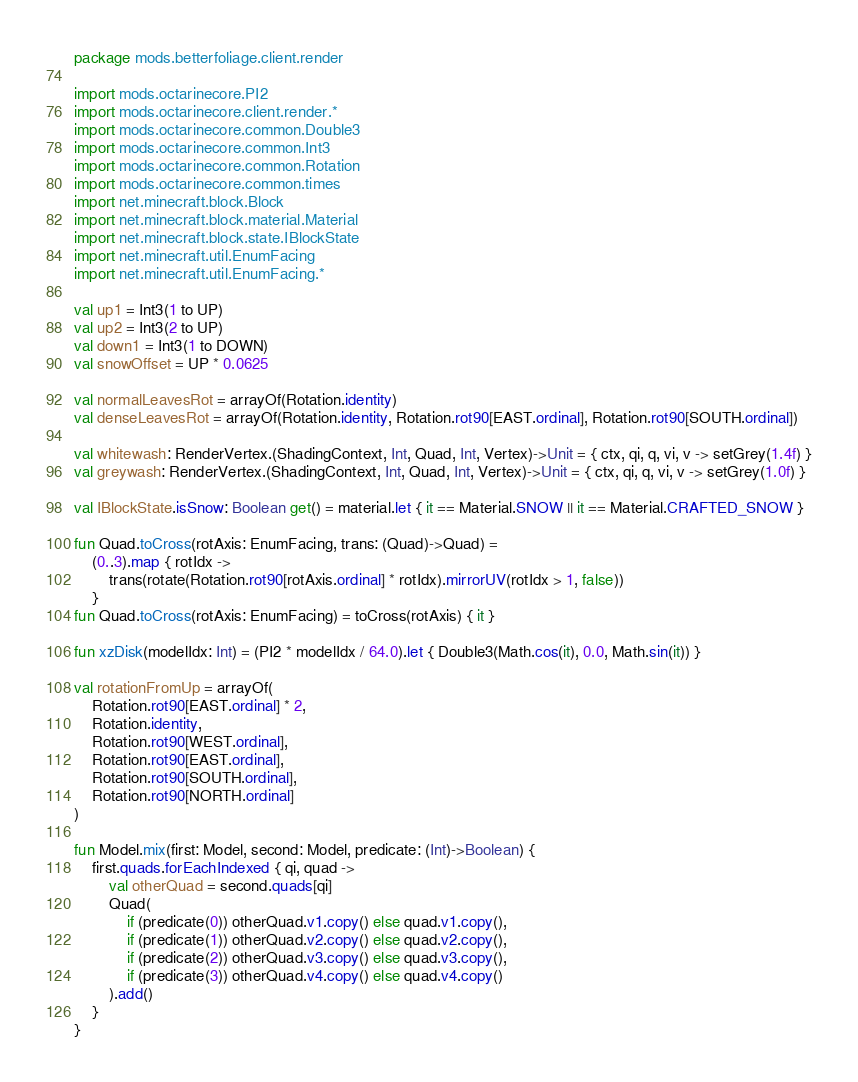Convert code to text. <code><loc_0><loc_0><loc_500><loc_500><_Kotlin_>package mods.betterfoliage.client.render

import mods.octarinecore.PI2
import mods.octarinecore.client.render.*
import mods.octarinecore.common.Double3
import mods.octarinecore.common.Int3
import mods.octarinecore.common.Rotation
import mods.octarinecore.common.times
import net.minecraft.block.Block
import net.minecraft.block.material.Material
import net.minecraft.block.state.IBlockState
import net.minecraft.util.EnumFacing
import net.minecraft.util.EnumFacing.*

val up1 = Int3(1 to UP)
val up2 = Int3(2 to UP)
val down1 = Int3(1 to DOWN)
val snowOffset = UP * 0.0625

val normalLeavesRot = arrayOf(Rotation.identity)
val denseLeavesRot = arrayOf(Rotation.identity, Rotation.rot90[EAST.ordinal], Rotation.rot90[SOUTH.ordinal])

val whitewash: RenderVertex.(ShadingContext, Int, Quad, Int, Vertex)->Unit = { ctx, qi, q, vi, v -> setGrey(1.4f) }
val greywash: RenderVertex.(ShadingContext, Int, Quad, Int, Vertex)->Unit = { ctx, qi, q, vi, v -> setGrey(1.0f) }

val IBlockState.isSnow: Boolean get() = material.let { it == Material.SNOW || it == Material.CRAFTED_SNOW }

fun Quad.toCross(rotAxis: EnumFacing, trans: (Quad)->Quad) =
    (0..3).map { rotIdx ->
        trans(rotate(Rotation.rot90[rotAxis.ordinal] * rotIdx).mirrorUV(rotIdx > 1, false))
    }
fun Quad.toCross(rotAxis: EnumFacing) = toCross(rotAxis) { it }

fun xzDisk(modelIdx: Int) = (PI2 * modelIdx / 64.0).let { Double3(Math.cos(it), 0.0, Math.sin(it)) }

val rotationFromUp = arrayOf(
    Rotation.rot90[EAST.ordinal] * 2,
    Rotation.identity,
    Rotation.rot90[WEST.ordinal],
    Rotation.rot90[EAST.ordinal],
    Rotation.rot90[SOUTH.ordinal],
    Rotation.rot90[NORTH.ordinal]
)

fun Model.mix(first: Model, second: Model, predicate: (Int)->Boolean) {
    first.quads.forEachIndexed { qi, quad ->
        val otherQuad = second.quads[qi]
        Quad(
            if (predicate(0)) otherQuad.v1.copy() else quad.v1.copy(),
            if (predicate(1)) otherQuad.v2.copy() else quad.v2.copy(),
            if (predicate(2)) otherQuad.v3.copy() else quad.v3.copy(),
            if (predicate(3)) otherQuad.v4.copy() else quad.v4.copy()
        ).add()
    }
}</code> 